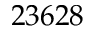<formula> <loc_0><loc_0><loc_500><loc_500>2 3 6 2 8</formula> 